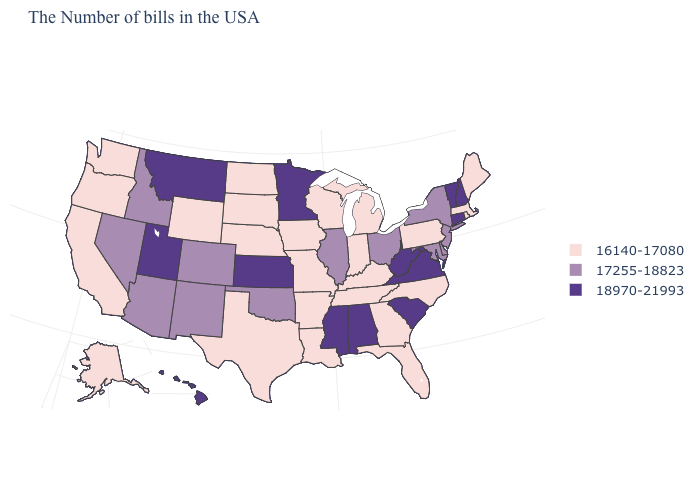Name the states that have a value in the range 17255-18823?
Write a very short answer. New York, New Jersey, Delaware, Maryland, Ohio, Illinois, Oklahoma, Colorado, New Mexico, Arizona, Idaho, Nevada. What is the value of Virginia?
Give a very brief answer. 18970-21993. What is the value of Texas?
Quick response, please. 16140-17080. Name the states that have a value in the range 18970-21993?
Write a very short answer. New Hampshire, Vermont, Connecticut, Virginia, South Carolina, West Virginia, Alabama, Mississippi, Minnesota, Kansas, Utah, Montana, Hawaii. Name the states that have a value in the range 16140-17080?
Give a very brief answer. Maine, Massachusetts, Rhode Island, Pennsylvania, North Carolina, Florida, Georgia, Michigan, Kentucky, Indiana, Tennessee, Wisconsin, Louisiana, Missouri, Arkansas, Iowa, Nebraska, Texas, South Dakota, North Dakota, Wyoming, California, Washington, Oregon, Alaska. Which states have the lowest value in the USA?
Short answer required. Maine, Massachusetts, Rhode Island, Pennsylvania, North Carolina, Florida, Georgia, Michigan, Kentucky, Indiana, Tennessee, Wisconsin, Louisiana, Missouri, Arkansas, Iowa, Nebraska, Texas, South Dakota, North Dakota, Wyoming, California, Washington, Oregon, Alaska. Name the states that have a value in the range 16140-17080?
Quick response, please. Maine, Massachusetts, Rhode Island, Pennsylvania, North Carolina, Florida, Georgia, Michigan, Kentucky, Indiana, Tennessee, Wisconsin, Louisiana, Missouri, Arkansas, Iowa, Nebraska, Texas, South Dakota, North Dakota, Wyoming, California, Washington, Oregon, Alaska. Name the states that have a value in the range 17255-18823?
Be succinct. New York, New Jersey, Delaware, Maryland, Ohio, Illinois, Oklahoma, Colorado, New Mexico, Arizona, Idaho, Nevada. What is the lowest value in the USA?
Give a very brief answer. 16140-17080. Name the states that have a value in the range 18970-21993?
Quick response, please. New Hampshire, Vermont, Connecticut, Virginia, South Carolina, West Virginia, Alabama, Mississippi, Minnesota, Kansas, Utah, Montana, Hawaii. What is the value of New Jersey?
Short answer required. 17255-18823. Does Maine have the same value as Arizona?
Write a very short answer. No. Does Minnesota have a lower value than Texas?
Keep it brief. No. 